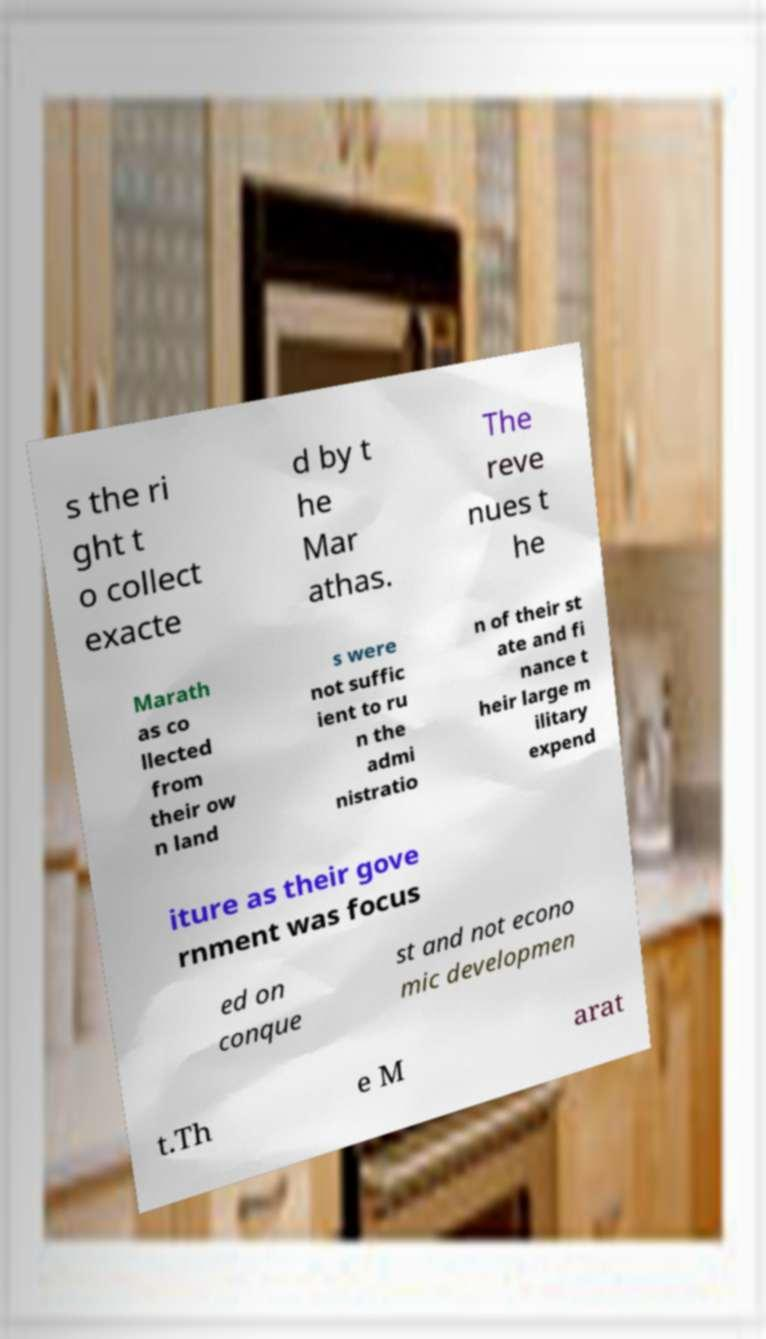Please identify and transcribe the text found in this image. s the ri ght t o collect exacte d by t he Mar athas. The reve nues t he Marath as co llected from their ow n land s were not suffic ient to ru n the admi nistratio n of their st ate and fi nance t heir large m ilitary expend iture as their gove rnment was focus ed on conque st and not econo mic developmen t.Th e M arat 